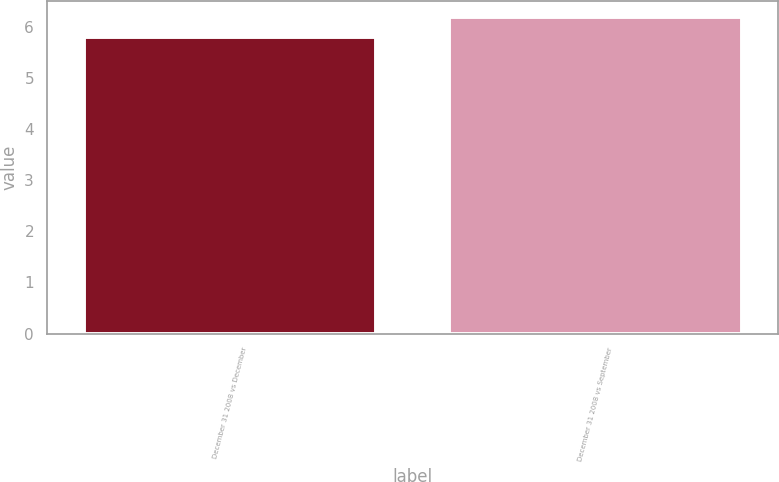<chart> <loc_0><loc_0><loc_500><loc_500><bar_chart><fcel>December 31 2008 vs December<fcel>December 31 2008 vs September<nl><fcel>5.8<fcel>6.2<nl></chart> 